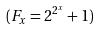<formula> <loc_0><loc_0><loc_500><loc_500>( F _ { x } = 2 ^ { 2 ^ { x } } + 1 )</formula> 